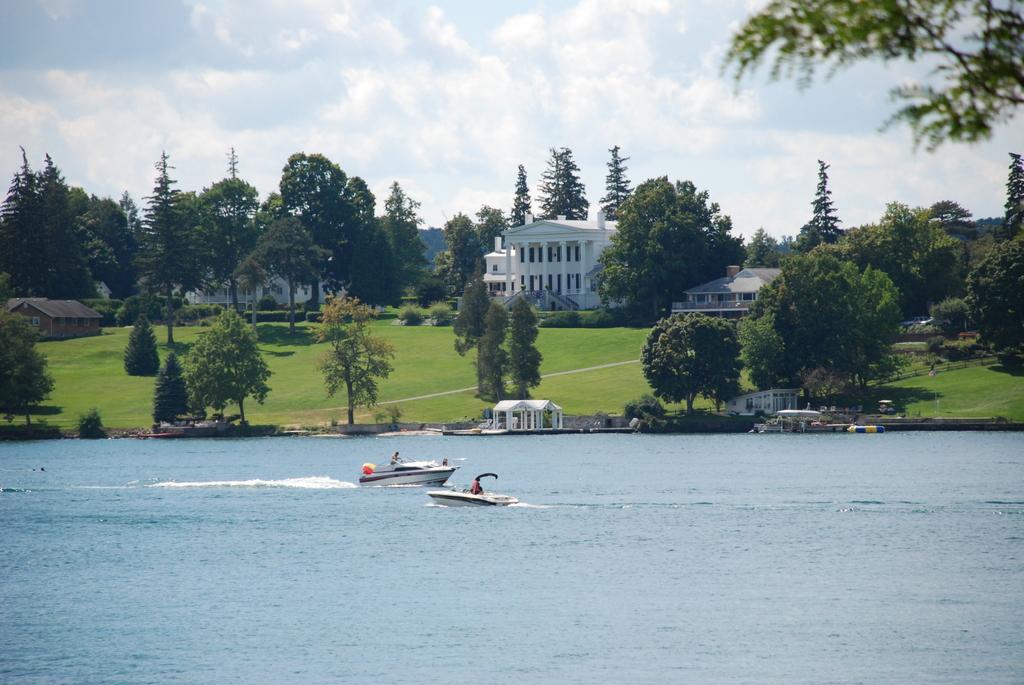Can you describe this image briefly? At the bottom of the image there is water. On the water there are two speed boats. Behind the water there are small roofs with pillars. Behind them there are trees in the background. In between them there are few houses and there is a big building which is white in color and also there are walls, pillars and windows. At the top of the image there is a sky with clouds. 